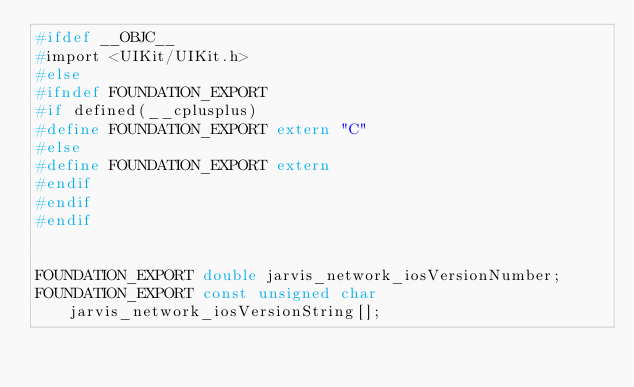Convert code to text. <code><loc_0><loc_0><loc_500><loc_500><_C_>#ifdef __OBJC__
#import <UIKit/UIKit.h>
#else
#ifndef FOUNDATION_EXPORT
#if defined(__cplusplus)
#define FOUNDATION_EXPORT extern "C"
#else
#define FOUNDATION_EXPORT extern
#endif
#endif
#endif


FOUNDATION_EXPORT double jarvis_network_iosVersionNumber;
FOUNDATION_EXPORT const unsigned char jarvis_network_iosVersionString[];

</code> 